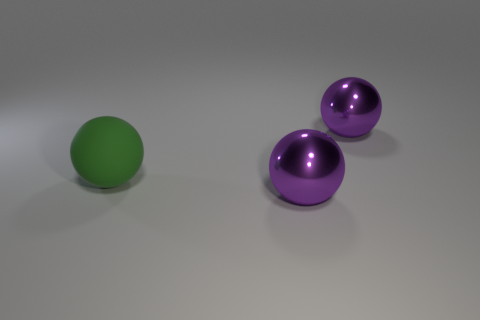Does the large purple ball behind the large green object have the same material as the ball in front of the big green matte sphere?
Provide a succinct answer. Yes. Are there more large yellow matte cylinders than large purple shiny balls?
Your response must be concise. No. Are there any other things that are the same color as the big rubber object?
Provide a succinct answer. No. Are there fewer objects than big matte balls?
Keep it short and to the point. No. The matte object has what color?
Your answer should be compact. Green. How many other objects are there of the same material as the green sphere?
Give a very brief answer. 0. What number of brown things are small cylinders or big rubber things?
Your response must be concise. 0. Does the metallic object in front of the large matte thing have the same shape as the big purple metallic thing that is behind the large green thing?
Keep it short and to the point. Yes. There is a rubber ball; is it the same color as the metal object that is in front of the large green thing?
Offer a terse response. No. Does the big metallic ball that is in front of the large matte thing have the same color as the rubber sphere?
Ensure brevity in your answer.  No. 